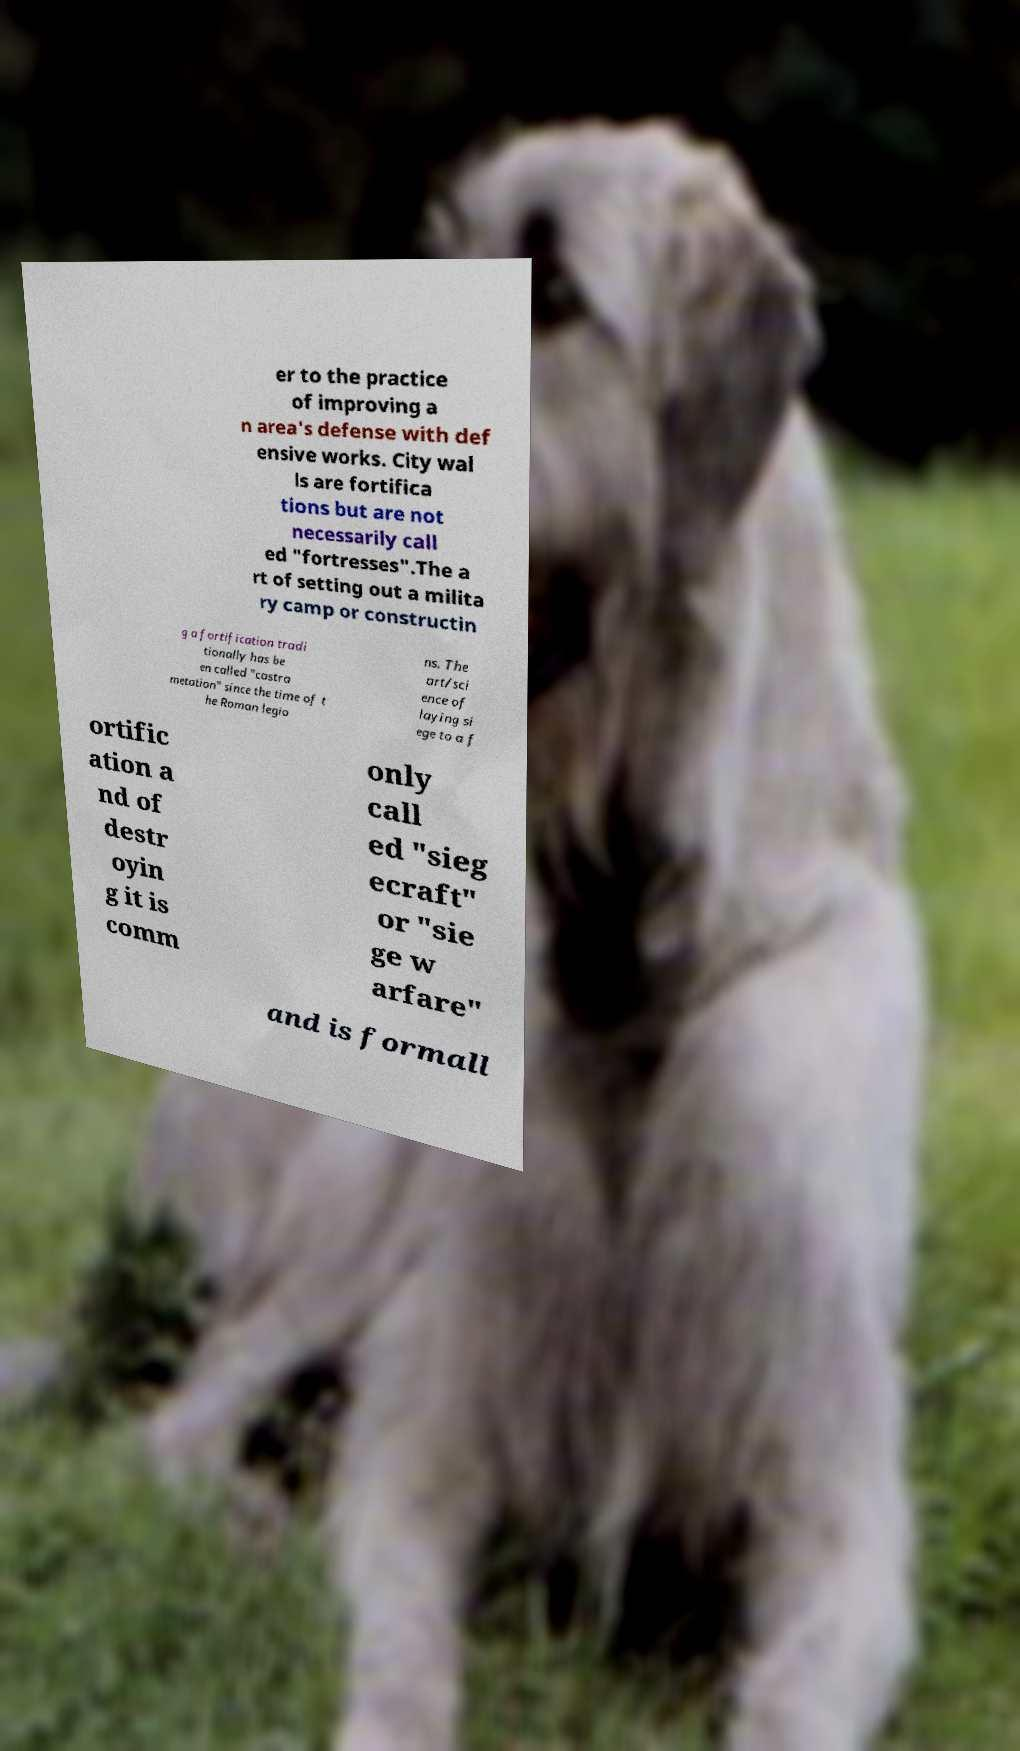There's text embedded in this image that I need extracted. Can you transcribe it verbatim? er to the practice of improving a n area's defense with def ensive works. City wal ls are fortifica tions but are not necessarily call ed "fortresses".The a rt of setting out a milita ry camp or constructin g a fortification tradi tionally has be en called "castra metation" since the time of t he Roman legio ns. The art/sci ence of laying si ege to a f ortific ation a nd of destr oyin g it is comm only call ed "sieg ecraft" or "sie ge w arfare" and is formall 